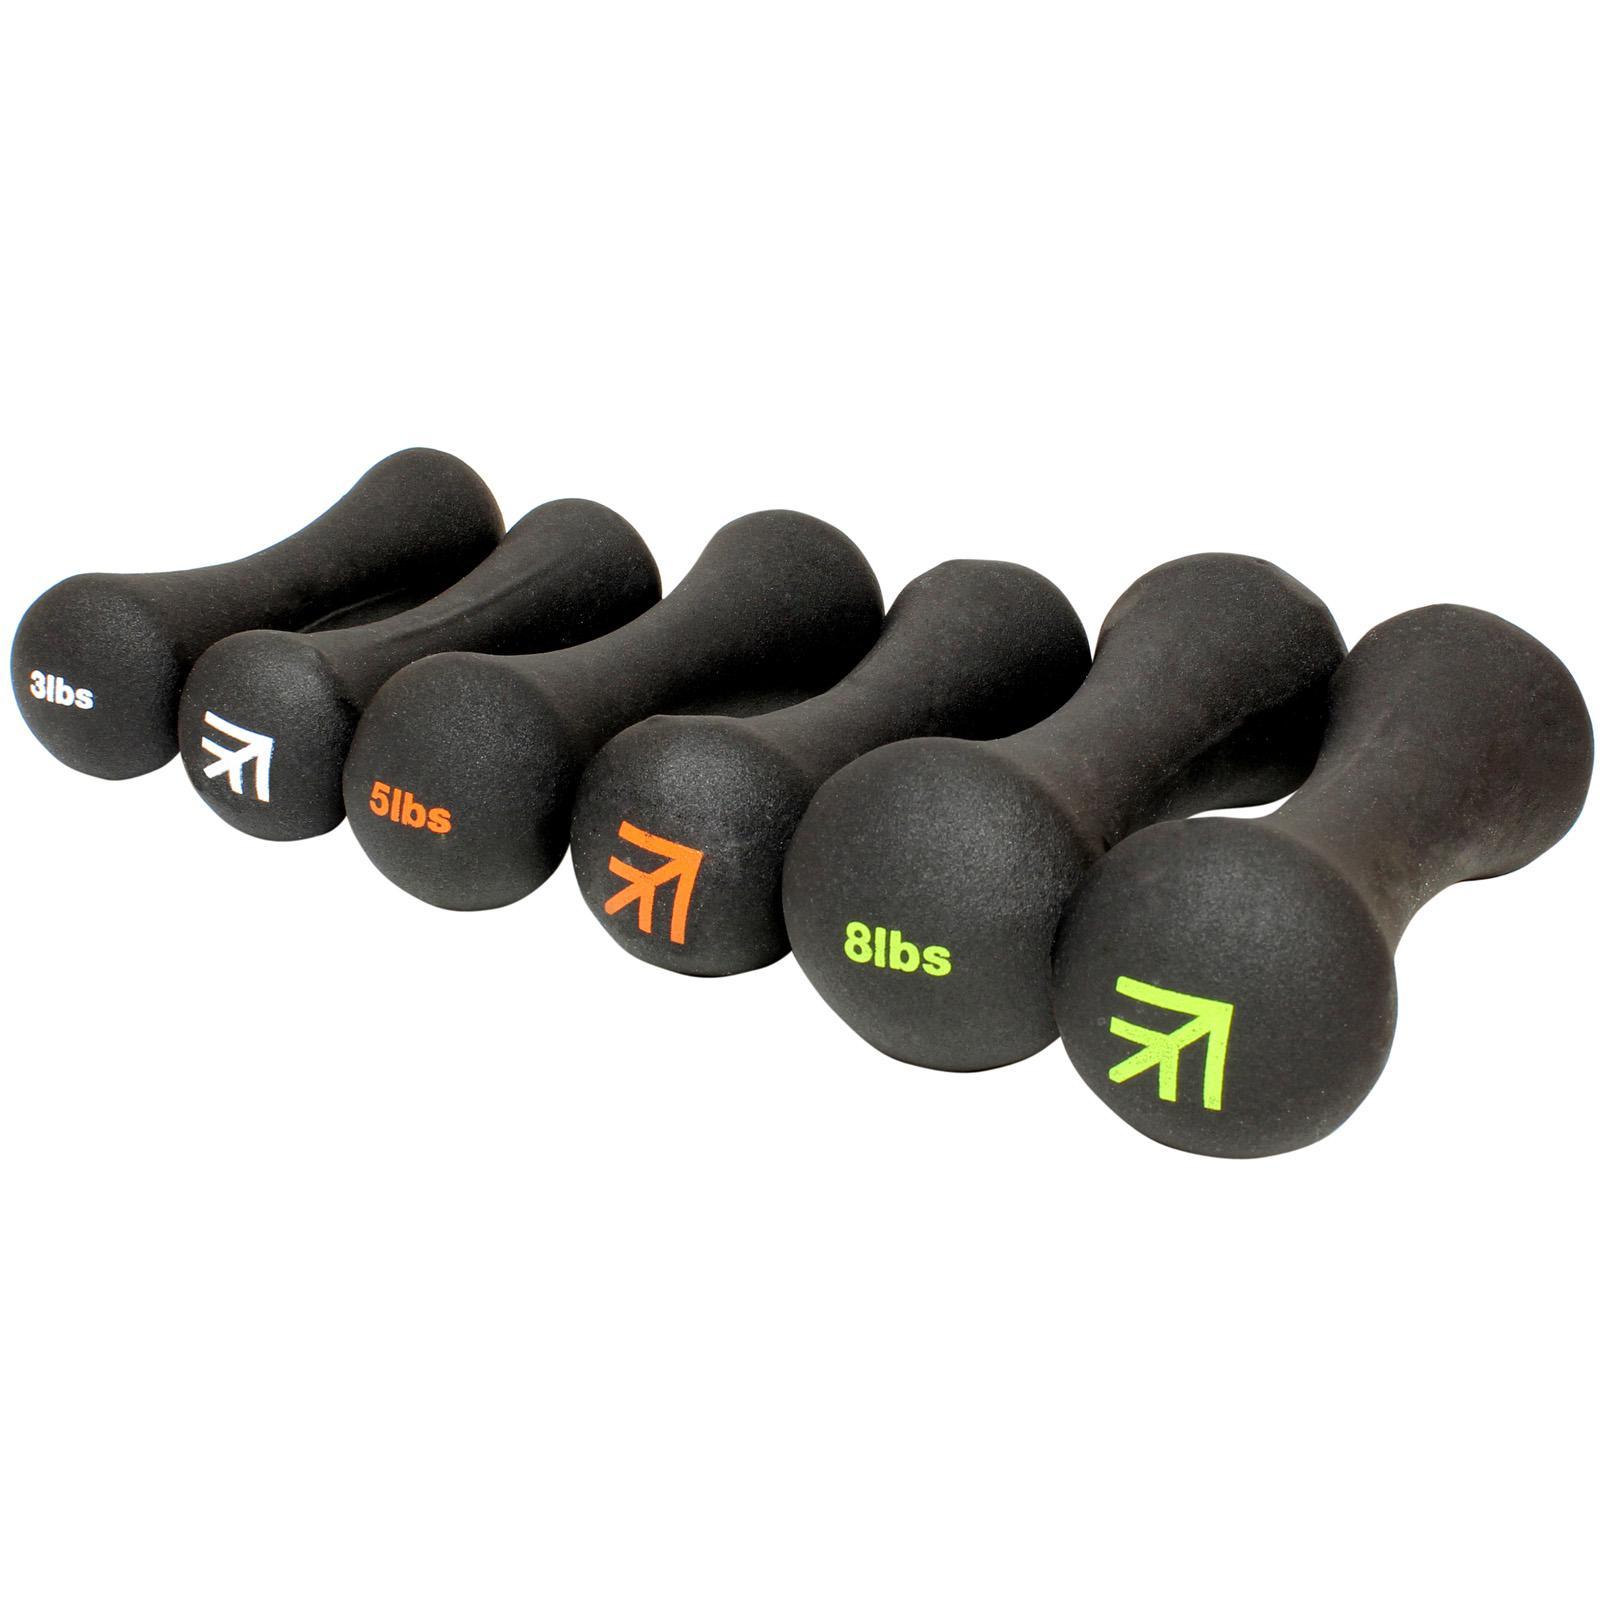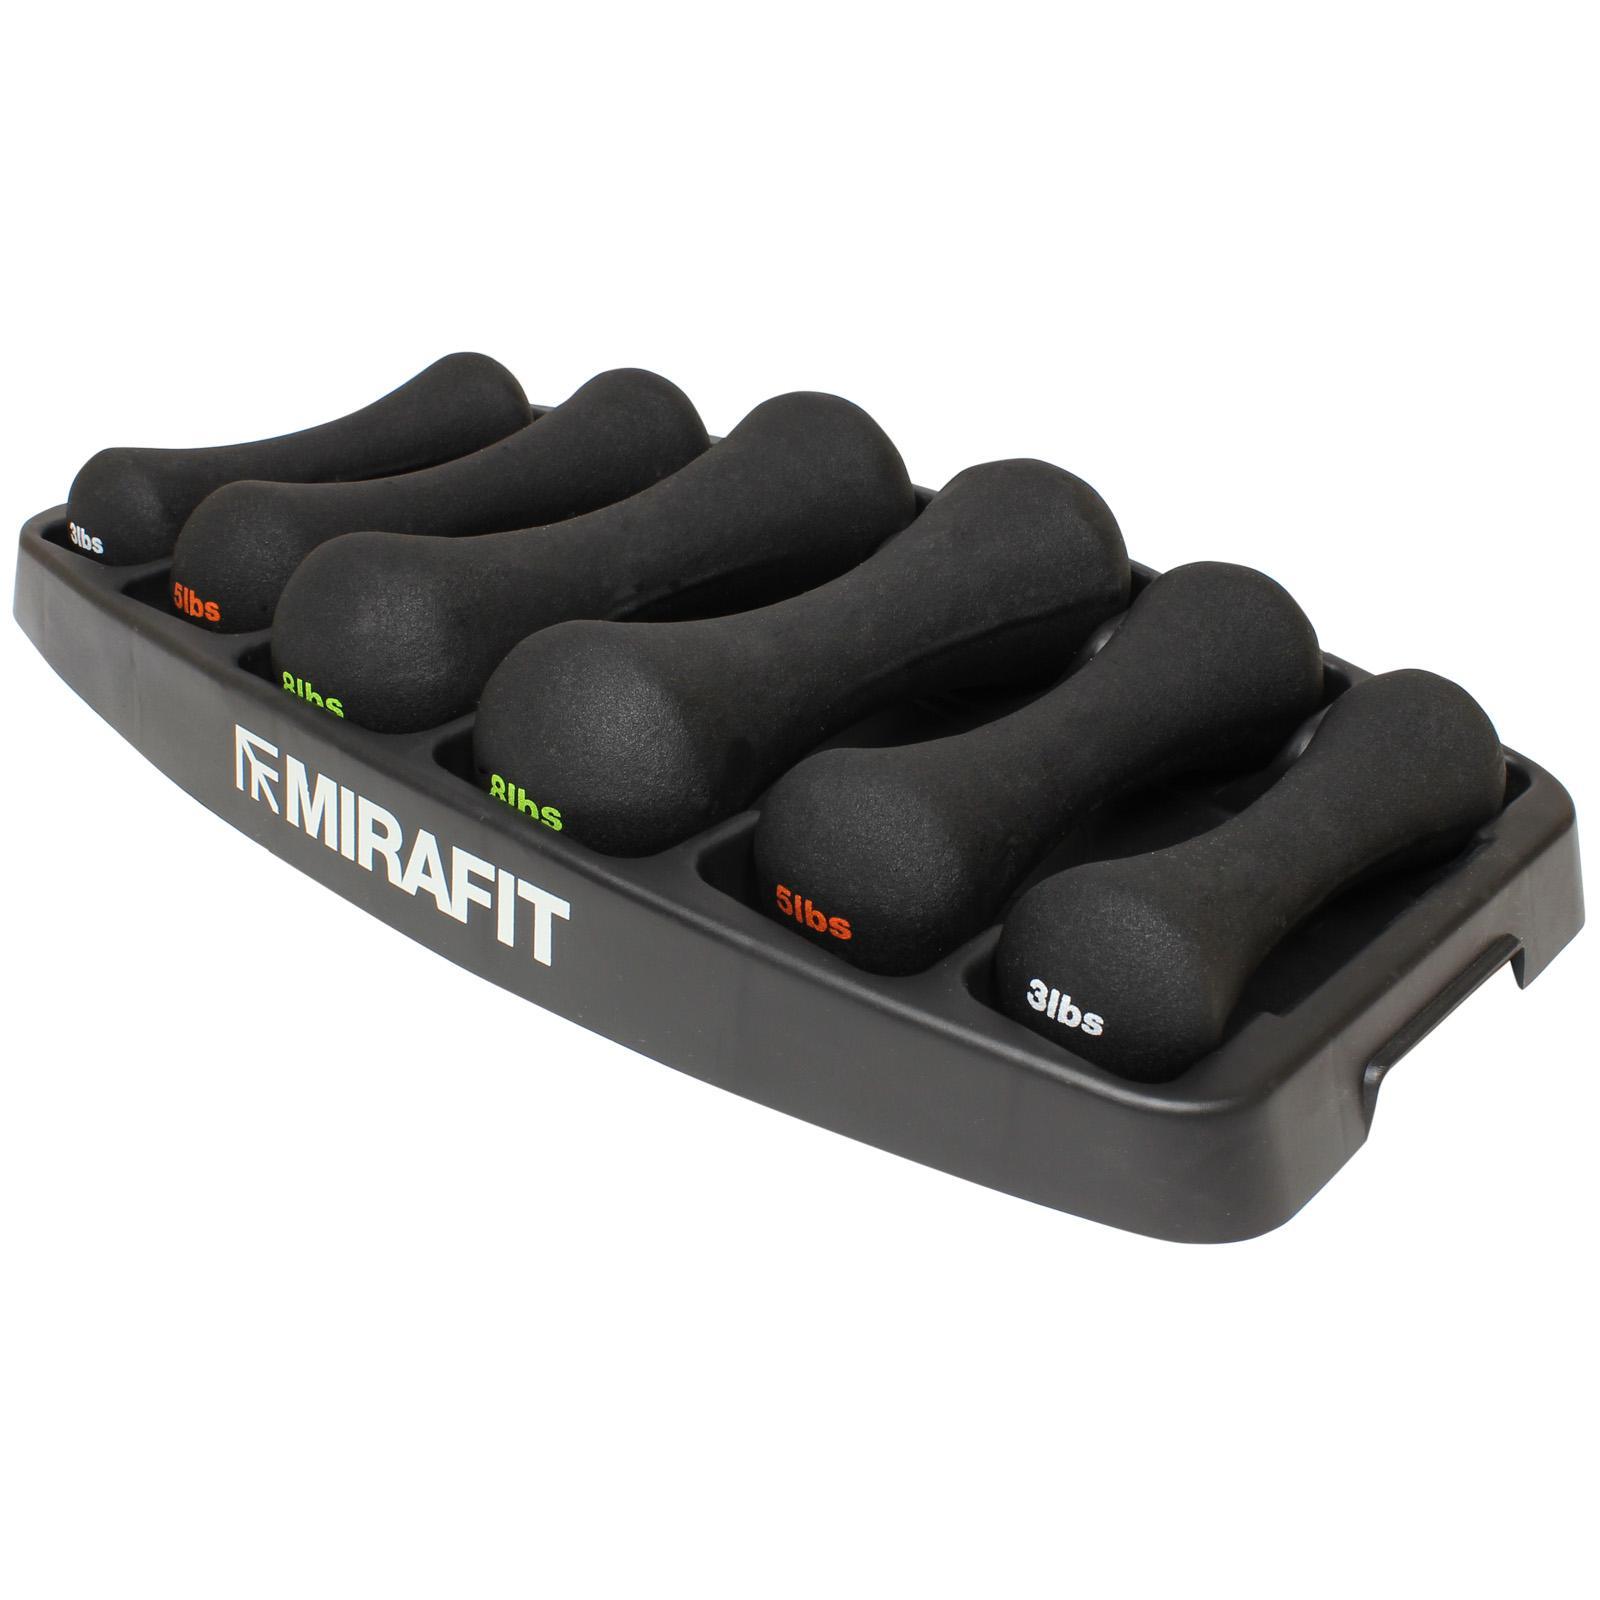The first image is the image on the left, the second image is the image on the right. Considering the images on both sides, is "Both images include separate dumbbell parts that require assembly." valid? Answer yes or no. No. The first image is the image on the left, the second image is the image on the right. Examine the images to the left and right. Is the description "The right image contains the disassembled parts for two barbells." accurate? Answer yes or no. No. 